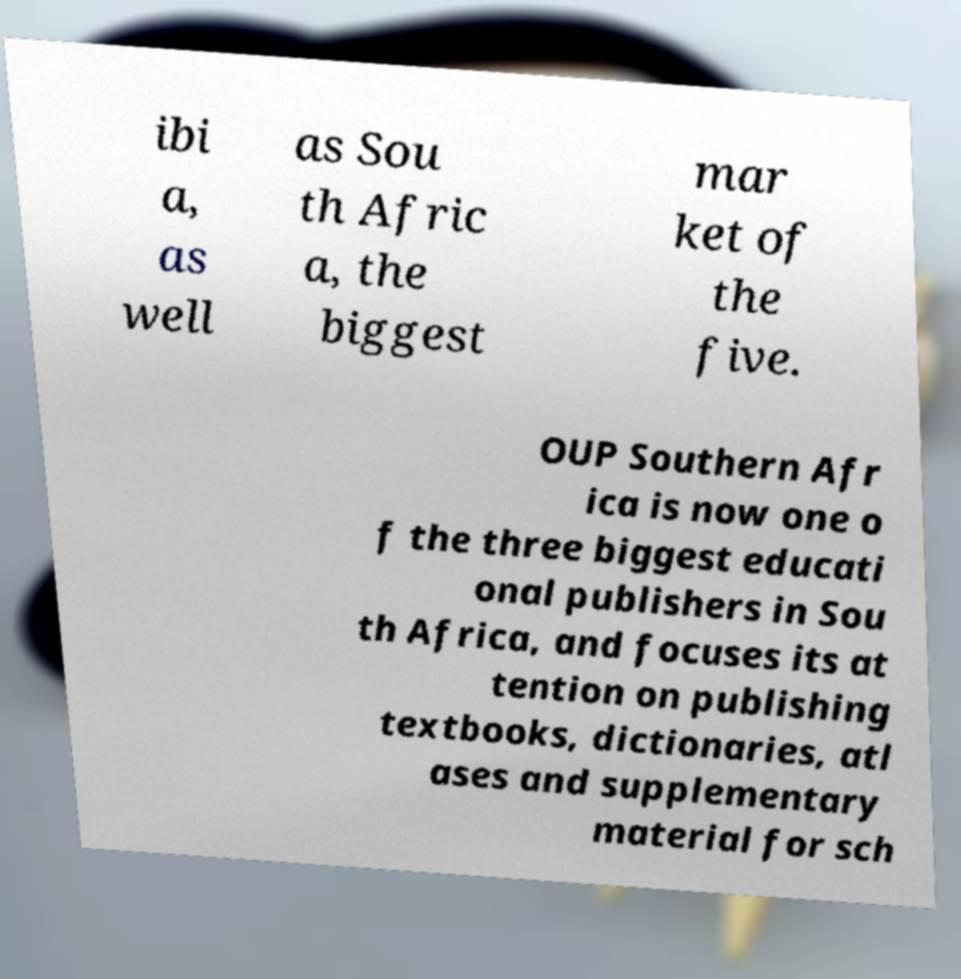What messages or text are displayed in this image? I need them in a readable, typed format. ibi a, as well as Sou th Afric a, the biggest mar ket of the five. OUP Southern Afr ica is now one o f the three biggest educati onal publishers in Sou th Africa, and focuses its at tention on publishing textbooks, dictionaries, atl ases and supplementary material for sch 